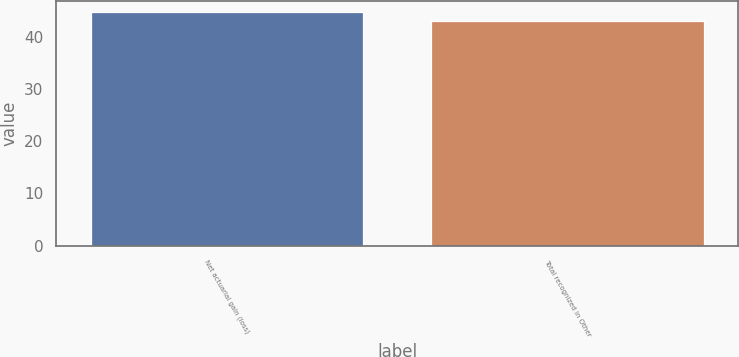Convert chart. <chart><loc_0><loc_0><loc_500><loc_500><bar_chart><fcel>Net actuarial gain (loss)<fcel>Total recognized in Other<nl><fcel>44.7<fcel>43.1<nl></chart> 